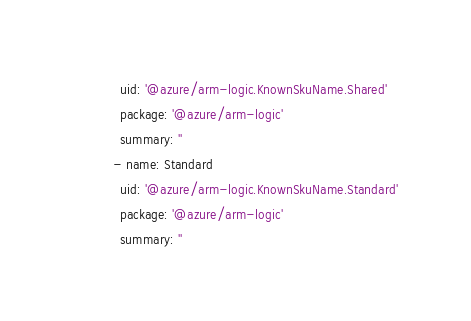Convert code to text. <code><loc_0><loc_0><loc_500><loc_500><_YAML_>    uid: '@azure/arm-logic.KnownSkuName.Shared'
    package: '@azure/arm-logic'
    summary: ''
  - name: Standard
    uid: '@azure/arm-logic.KnownSkuName.Standard'
    package: '@azure/arm-logic'
    summary: ''
</code> 